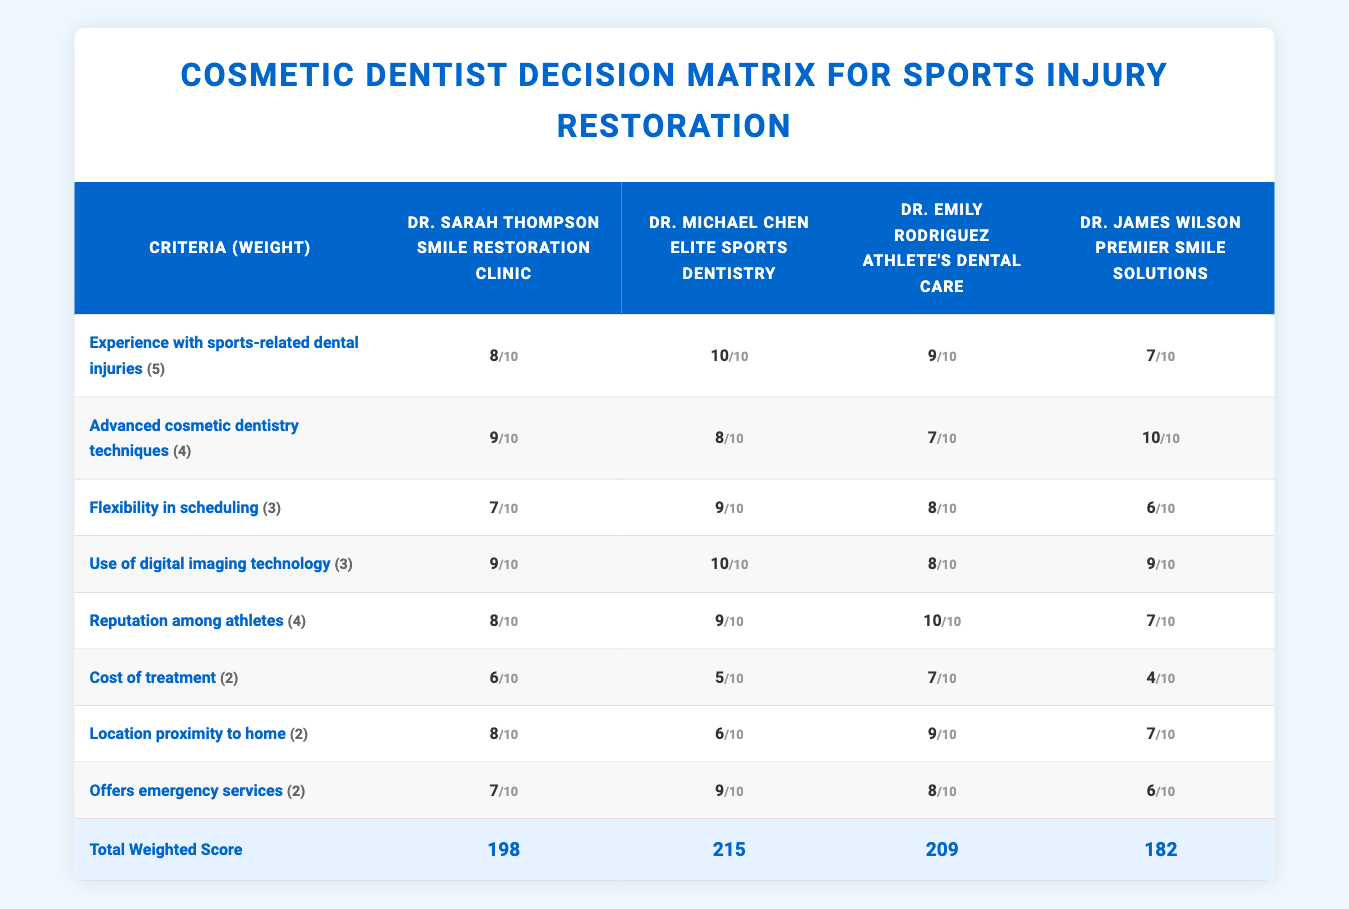What is the total weighted score for Dr. Michael Chen? The total weighted score for Dr. Michael Chen is directly listed in the last row of the table under his name, which indicates a score of 207.
Answer: 207 Which dentist has the highest score for "Experience with sports-related dental injuries"? By comparing the scores in that particular row for each dentist, Dr. Michael Chen scores 10, which is the highest among all.
Answer: Dr. Michael Chen What is the average score for the "Cost of treatment" across all dentists? The scores for "Cost of treatment" are as follows: 6, 5, 7, and 4. Adding these gives 6 + 5 + 7 + 4 = 22. Dividing by the number of dentists (4) gives an average of 22/4 = 5.5.
Answer: 5.5 Is Dr. Emily Rodriguez's reputation among athletes equal to Dr. Sarah Thompson's rating in the same category? Dr. Emily Rodriguez has a score of 10 for "Reputation among athletes," while Dr. Sarah Thompson has an 8. Therefore, the statement that their ratings are equal is false.
Answer: No If you prioritize "Use of digital imaging technology" over other criteria, should you choose Dr. Michael Chen? Considering "Use of digital imaging technology," Dr. Michael Chen has the highest score (10). This is a significant factor for a decision based on advanced technology in dentistry, indicating he would be a suitable choice.
Answer: Yes Which dentist has the lowest score for "Cost of treatment"? The ratings for "Cost of treatment" are 6 for Dr. Sarah Thompson, 5 for Dr. Michael Chen, 7 for Dr. Emily Rodriguez, and 4 for Dr. James Wilson. Therefore, Dr. James Wilson has the lowest score of 4 in this category.
Answer: Dr. James Wilson What is the difference in the total weighted scores between Dr. Emily Rodriguez and Dr. James Wilson? Dr. Emily Rodriguez has a total weighted score of 204 and Dr. James Wilson has a score of 183. The difference is calculated as 204 - 183 = 21.
Answer: 21 Which criteria did Dr. James Wilson score the highest in? Looking at Dr. James Wilson's scores, the maximum is 10 for "Advanced cosmetic dentistry techniques." This is where he excelled the most compared to other criteria.
Answer: Advanced cosmetic dentistry techniques 